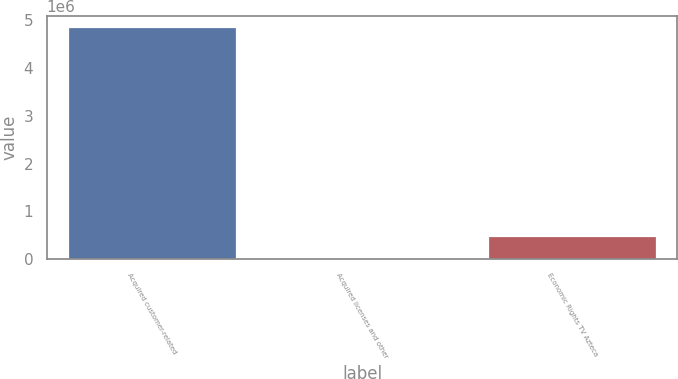Convert chart. <chart><loc_0><loc_0><loc_500><loc_500><bar_chart><fcel>Acquired customer-related<fcel>Acquired licenses and other<fcel>Economic Rights TV Azteca<nl><fcel>4.84761e+06<fcel>4286<fcel>488618<nl></chart> 